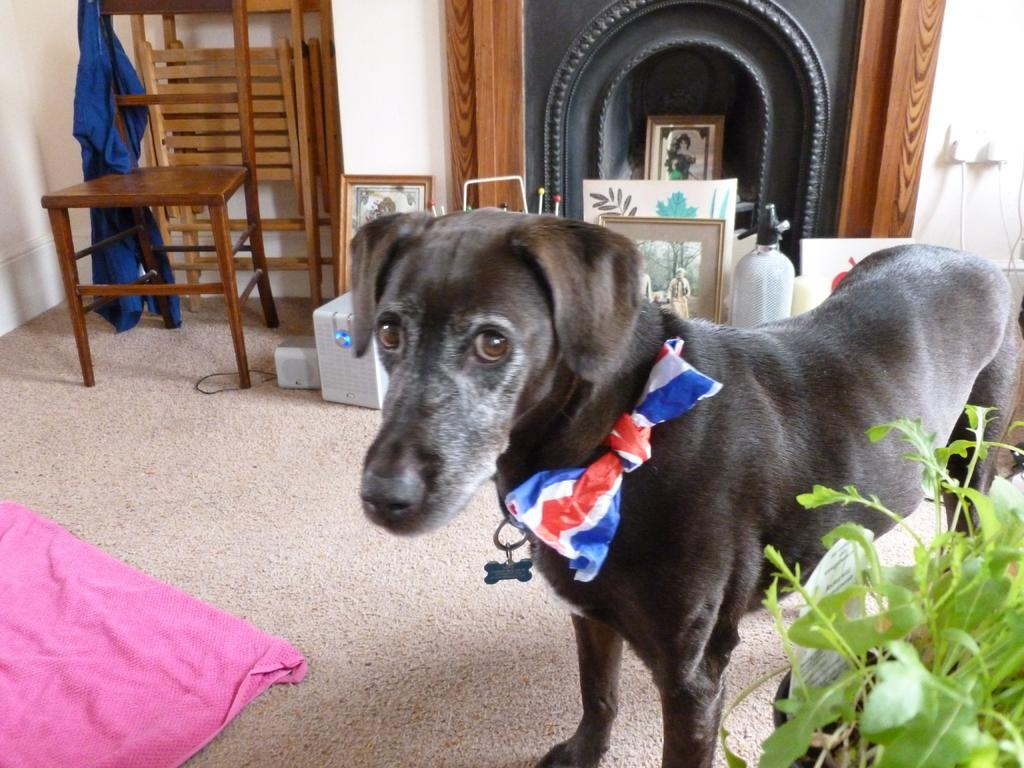What animal is on the floor in the image? There is a dog on the floor in the image. What type of object can be seen near the dog? There is a flower pot in the image. What type of furniture is present in the image? There are chairs in the image. What type of decorative items are present in the image? There are photo frames in the image. How many legs does the hook have in the image? There is no hook present in the image, so it is not possible to determine the number of legs it might have. 